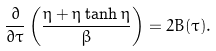Convert formula to latex. <formula><loc_0><loc_0><loc_500><loc_500>\frac { \partial } { \partial \tau } \left ( \frac { \eta + \eta \tanh \eta } { \beta } \right ) = 2 B ( \tau ) .</formula> 